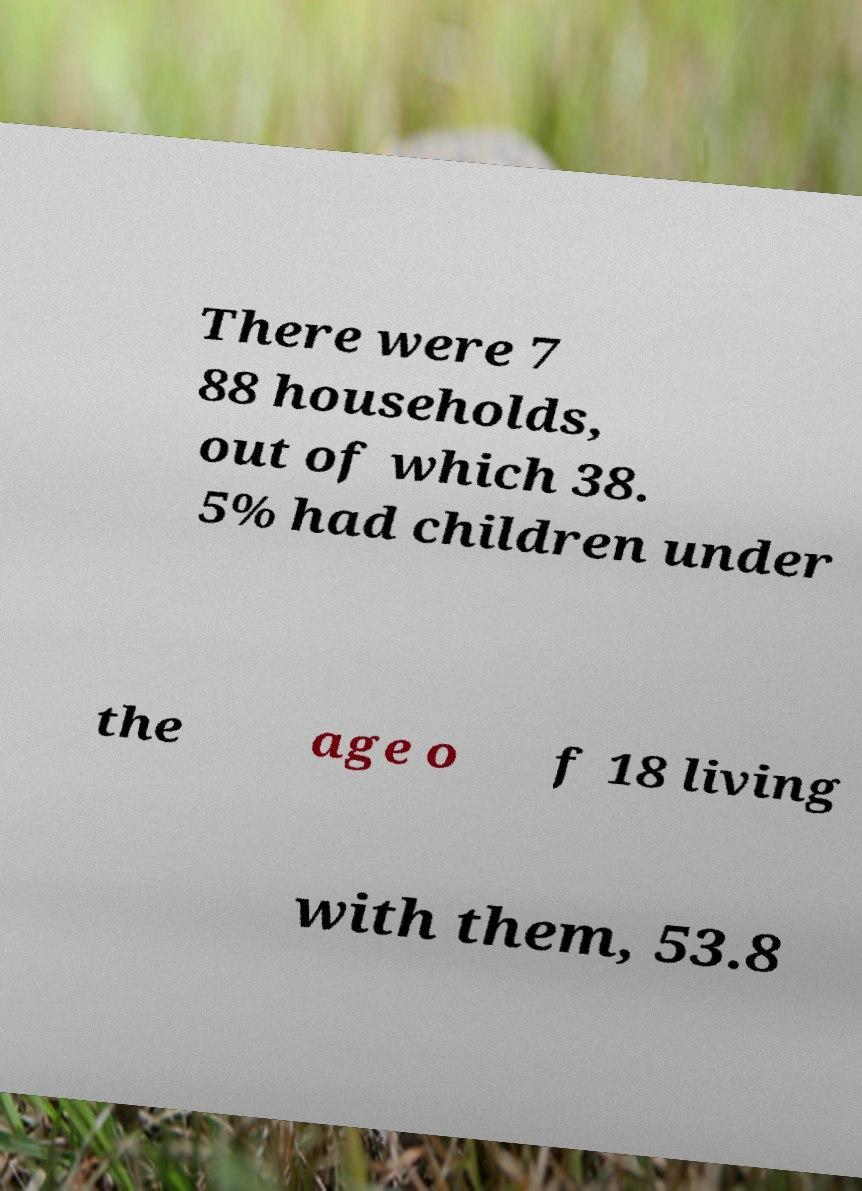I need the written content from this picture converted into text. Can you do that? There were 7 88 households, out of which 38. 5% had children under the age o f 18 living with them, 53.8 